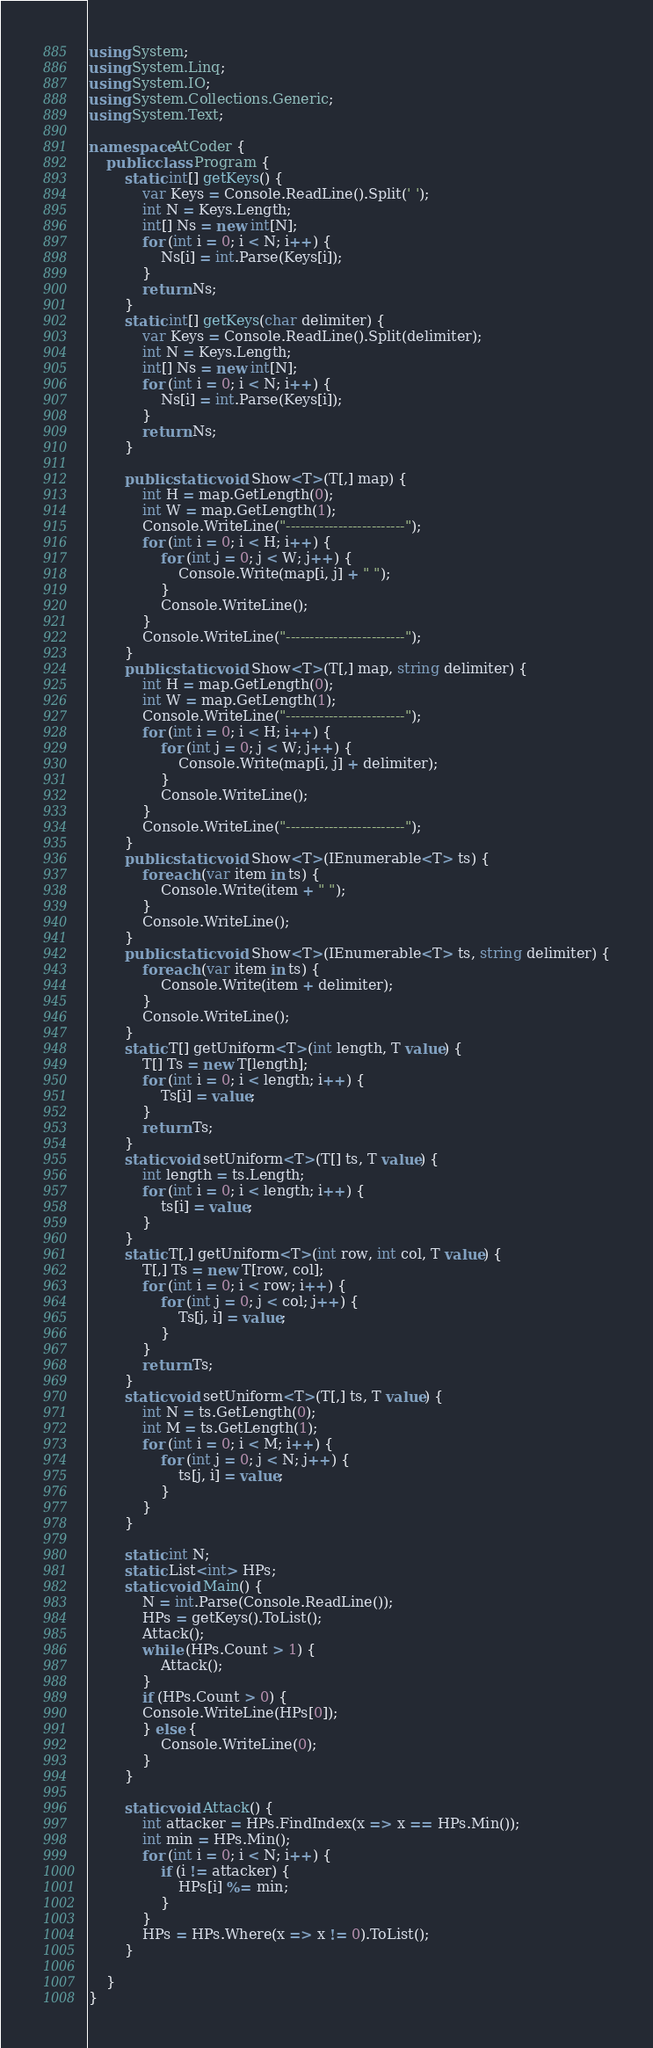Convert code to text. <code><loc_0><loc_0><loc_500><loc_500><_C#_>using System;
using System.Linq;
using System.IO;
using System.Collections.Generic;
using System.Text;

namespace AtCoder {
    public class Program {
        static int[] getKeys() {
            var Keys = Console.ReadLine().Split(' ');
            int N = Keys.Length;
            int[] Ns = new int[N];
            for (int i = 0; i < N; i++) {
                Ns[i] = int.Parse(Keys[i]);
            }
            return Ns;
        }
        static int[] getKeys(char delimiter) {
            var Keys = Console.ReadLine().Split(delimiter);
            int N = Keys.Length;
            int[] Ns = new int[N];
            for (int i = 0; i < N; i++) {
                Ns[i] = int.Parse(Keys[i]);
            }
            return Ns;
        }

        public static void Show<T>(T[,] map) {
            int H = map.GetLength(0);
            int W = map.GetLength(1);
            Console.WriteLine("-------------------------");
            for (int i = 0; i < H; i++) {
                for (int j = 0; j < W; j++) {
                    Console.Write(map[i, j] + " ");
                }
                Console.WriteLine();
            }
            Console.WriteLine("-------------------------");
        }
        public static void Show<T>(T[,] map, string delimiter) {
            int H = map.GetLength(0);
            int W = map.GetLength(1);
            Console.WriteLine("-------------------------");
            for (int i = 0; i < H; i++) {
                for (int j = 0; j < W; j++) {
                    Console.Write(map[i, j] + delimiter);
                }
                Console.WriteLine();
            }
            Console.WriteLine("-------------------------");
        }
        public static void Show<T>(IEnumerable<T> ts) {
            foreach (var item in ts) {
                Console.Write(item + " ");
            }
            Console.WriteLine();
        }
        public static void Show<T>(IEnumerable<T> ts, string delimiter) {
            foreach (var item in ts) {
                Console.Write(item + delimiter);
            }
            Console.WriteLine();
        }
        static T[] getUniform<T>(int length, T value) {
            T[] Ts = new T[length];
            for (int i = 0; i < length; i++) {
                Ts[i] = value;
            }
            return Ts;
        }
        static void setUniform<T>(T[] ts, T value) {
            int length = ts.Length;
            for (int i = 0; i < length; i++) {
                ts[i] = value;
            }
        }
        static T[,] getUniform<T>(int row, int col, T value) {
            T[,] Ts = new T[row, col];
            for (int i = 0; i < row; i++) {
                for (int j = 0; j < col; j++) {
                    Ts[j, i] = value;
                }
            }
            return Ts;
        }
        static void setUniform<T>(T[,] ts, T value) {
            int N = ts.GetLength(0);
            int M = ts.GetLength(1);
            for (int i = 0; i < M; i++) {
                for (int j = 0; j < N; j++) {
                    ts[j, i] = value;
                }
            }
        }

        static int N;
        static List<int> HPs;
        static void Main() {
            N = int.Parse(Console.ReadLine());
            HPs = getKeys().ToList();
            Attack();
            while (HPs.Count > 1) {
                Attack();
            }
            if (HPs.Count > 0) {
            Console.WriteLine(HPs[0]);
            } else {
                Console.WriteLine(0);
            }
        }

        static void Attack() {
            int attacker = HPs.FindIndex(x => x == HPs.Min());
            int min = HPs.Min();
            for (int i = 0; i < N; i++) {
                if (i != attacker) {
                    HPs[i] %= min;
                }
            }
            HPs = HPs.Where(x => x != 0).ToList();
        }

    }
}</code> 